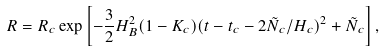Convert formula to latex. <formula><loc_0><loc_0><loc_500><loc_500>R = R _ { c } \exp \left [ - \frac { 3 } { 2 } H _ { B } ^ { 2 } ( 1 - K _ { c } ) ( t - t _ { c } - 2 \tilde { N } _ { c } / H _ { c } ) ^ { 2 } + \tilde { N } _ { c } \right ] ,</formula> 